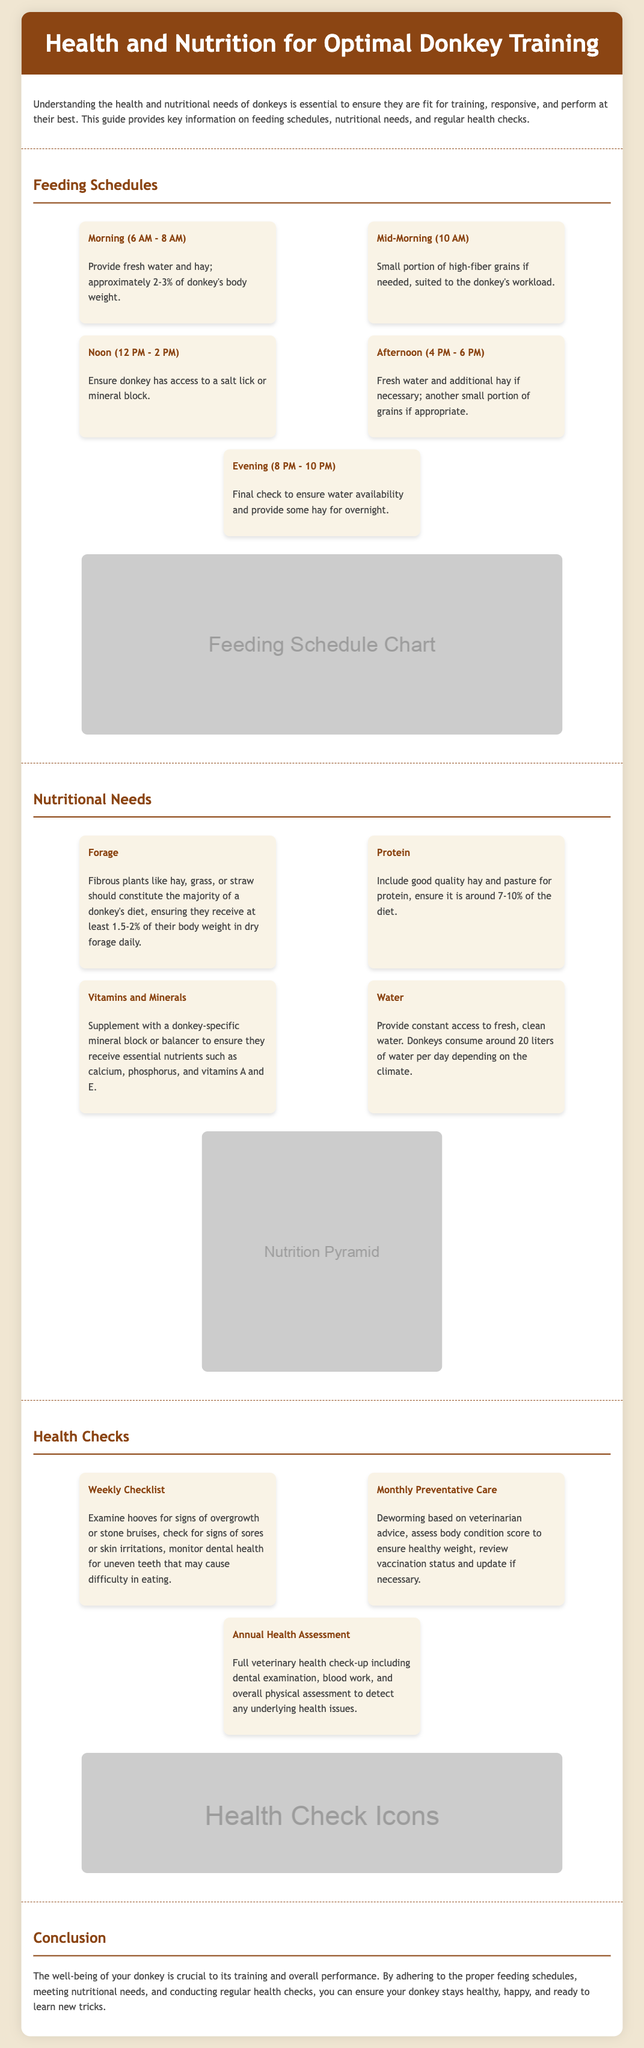What is the main focus of the infographic? The infographic focuses on health and nutrition for optimizing donkey training, which includes feeding schedules, nutritional needs, and health checks.
Answer: Health and nutrition for optimal donkey training What time is the evening feeding scheduled? The evening feeding is scheduled between 8 PM and 10 PM.
Answer: 8 PM - 10 PM What percentage of their body weight in dry forage should donkeys receive daily? Donkeys should receive at least 1.5-2% of their body weight in dry forage daily.
Answer: 1.5-2% What should be included in the weekly health checklist? The weekly health checklist includes examining hooves, checking for sores, and monitoring dental health.
Answer: Examine hooves, check for sores, monitor dental health How often should deworming be done? Deworming should be done monthly based on veterinarian advice.
Answer: Monthly What is the purpose of a mineral block? A mineral block is meant to supplement donkeys with essential nutrients like calcium and phosphorus.
Answer: Supplement essential nutrients What does the feeding schedule recommend at noon? At noon, the feeding schedule recommends ensuring access to a salt lick or mineral block.
Answer: Access to a salt lick or mineral block What is the ideal protein percentage in a donkey's diet? The ideal protein percentage in a donkey's diet should be around 7-10%.
Answer: 7-10% How many liters of water do donkeys consume per day? Donkeys consume around 20 liters of water per day depending on the climate.
Answer: 20 liters 